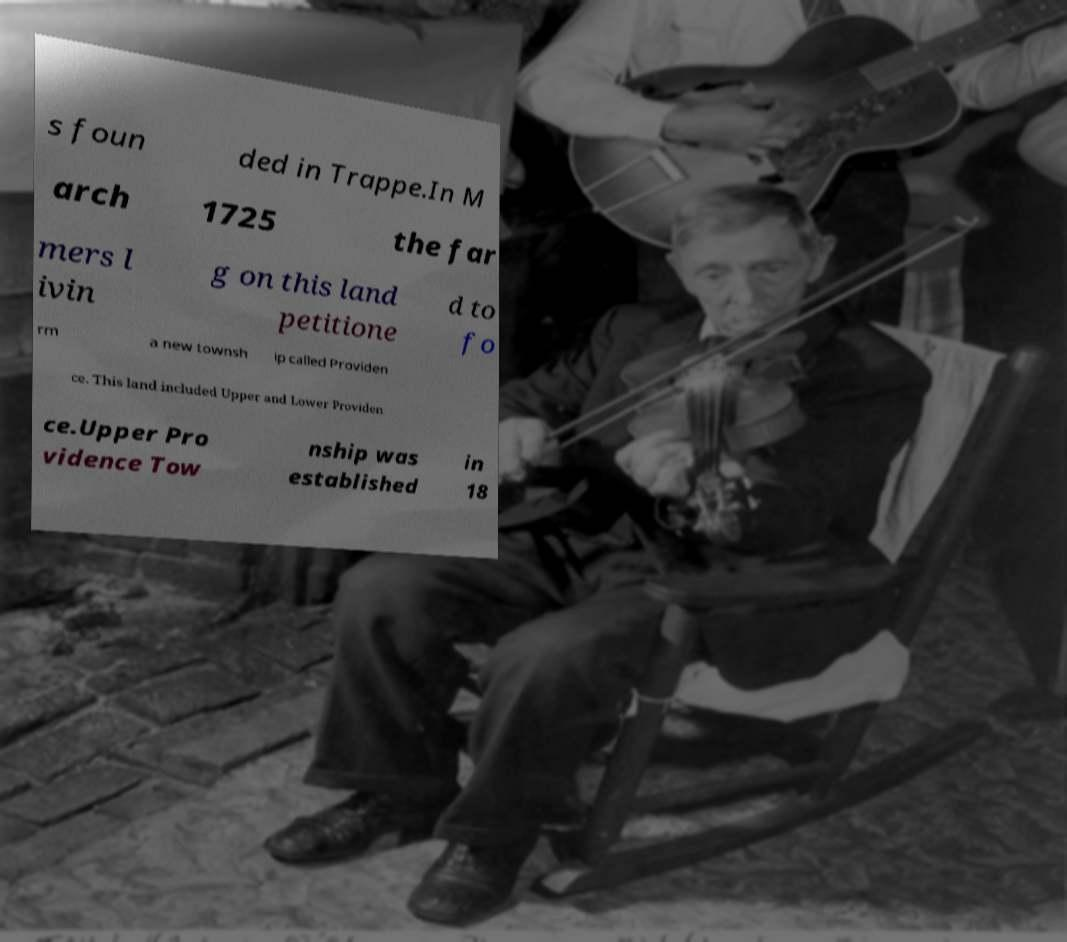There's text embedded in this image that I need extracted. Can you transcribe it verbatim? s foun ded in Trappe.In M arch 1725 the far mers l ivin g on this land petitione d to fo rm a new townsh ip called Providen ce. This land included Upper and Lower Providen ce.Upper Pro vidence Tow nship was established in 18 